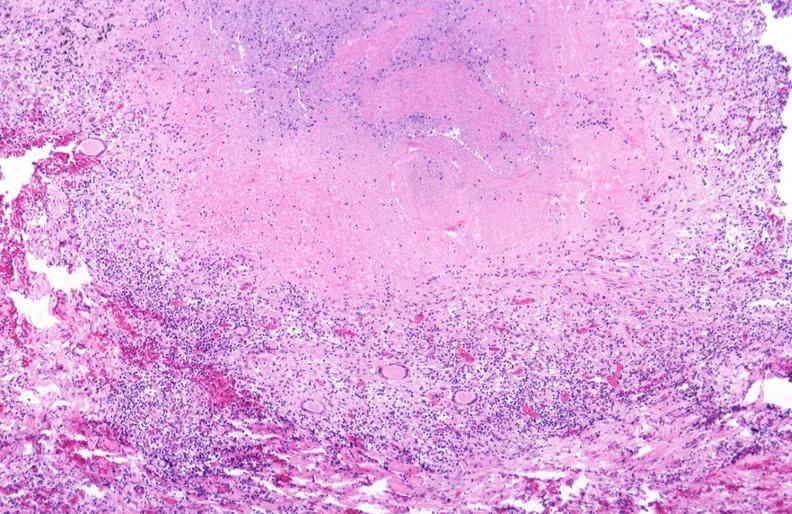where is this?
Answer the question using a single word or phrase. Lung 